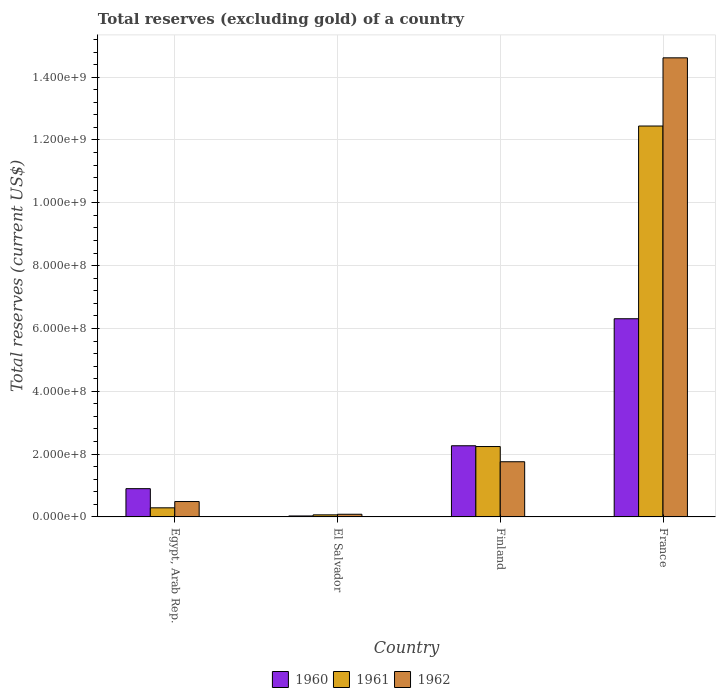How many groups of bars are there?
Your answer should be very brief. 4. Are the number of bars per tick equal to the number of legend labels?
Give a very brief answer. Yes. In how many cases, is the number of bars for a given country not equal to the number of legend labels?
Make the answer very short. 0. What is the total reserves (excluding gold) in 1960 in Egypt, Arab Rep.?
Provide a short and direct response. 9.00e+07. Across all countries, what is the maximum total reserves (excluding gold) in 1961?
Your answer should be very brief. 1.24e+09. Across all countries, what is the minimum total reserves (excluding gold) in 1960?
Give a very brief answer. 3.10e+06. In which country was the total reserves (excluding gold) in 1962 maximum?
Ensure brevity in your answer.  France. In which country was the total reserves (excluding gold) in 1960 minimum?
Your answer should be compact. El Salvador. What is the total total reserves (excluding gold) in 1960 in the graph?
Keep it short and to the point. 9.51e+08. What is the difference between the total reserves (excluding gold) in 1962 in Egypt, Arab Rep. and that in France?
Make the answer very short. -1.41e+09. What is the difference between the total reserves (excluding gold) in 1961 in France and the total reserves (excluding gold) in 1960 in El Salvador?
Your answer should be very brief. 1.24e+09. What is the average total reserves (excluding gold) in 1960 per country?
Your response must be concise. 2.38e+08. What is the difference between the total reserves (excluding gold) of/in 1962 and total reserves (excluding gold) of/in 1961 in France?
Offer a terse response. 2.17e+08. What is the ratio of the total reserves (excluding gold) in 1960 in Egypt, Arab Rep. to that in France?
Offer a terse response. 0.14. What is the difference between the highest and the second highest total reserves (excluding gold) in 1962?
Offer a terse response. -1.27e+08. What is the difference between the highest and the lowest total reserves (excluding gold) in 1961?
Keep it short and to the point. 1.24e+09. In how many countries, is the total reserves (excluding gold) in 1960 greater than the average total reserves (excluding gold) in 1960 taken over all countries?
Ensure brevity in your answer.  1. Is the sum of the total reserves (excluding gold) in 1962 in Egypt, Arab Rep. and Finland greater than the maximum total reserves (excluding gold) in 1961 across all countries?
Provide a short and direct response. No. What does the 2nd bar from the left in El Salvador represents?
Ensure brevity in your answer.  1961. Is it the case that in every country, the sum of the total reserves (excluding gold) in 1962 and total reserves (excluding gold) in 1960 is greater than the total reserves (excluding gold) in 1961?
Give a very brief answer. Yes. How many bars are there?
Give a very brief answer. 12. Are all the bars in the graph horizontal?
Keep it short and to the point. No. How many countries are there in the graph?
Give a very brief answer. 4. What is the difference between two consecutive major ticks on the Y-axis?
Keep it short and to the point. 2.00e+08. Does the graph contain any zero values?
Provide a short and direct response. No. Where does the legend appear in the graph?
Provide a succinct answer. Bottom center. How many legend labels are there?
Make the answer very short. 3. What is the title of the graph?
Provide a short and direct response. Total reserves (excluding gold) of a country. What is the label or title of the X-axis?
Give a very brief answer. Country. What is the label or title of the Y-axis?
Give a very brief answer. Total reserves (current US$). What is the Total reserves (current US$) in 1960 in Egypt, Arab Rep.?
Make the answer very short. 9.00e+07. What is the Total reserves (current US$) in 1961 in Egypt, Arab Rep.?
Provide a short and direct response. 2.90e+07. What is the Total reserves (current US$) in 1962 in Egypt, Arab Rep.?
Give a very brief answer. 4.90e+07. What is the Total reserves (current US$) of 1960 in El Salvador?
Your answer should be compact. 3.10e+06. What is the Total reserves (current US$) of 1961 in El Salvador?
Ensure brevity in your answer.  6.60e+06. What is the Total reserves (current US$) in 1962 in El Salvador?
Give a very brief answer. 8.51e+06. What is the Total reserves (current US$) in 1960 in Finland?
Offer a terse response. 2.27e+08. What is the Total reserves (current US$) in 1961 in Finland?
Ensure brevity in your answer.  2.24e+08. What is the Total reserves (current US$) of 1962 in Finland?
Your answer should be very brief. 1.76e+08. What is the Total reserves (current US$) in 1960 in France?
Offer a very short reply. 6.31e+08. What is the Total reserves (current US$) of 1961 in France?
Offer a very short reply. 1.24e+09. What is the Total reserves (current US$) in 1962 in France?
Ensure brevity in your answer.  1.46e+09. Across all countries, what is the maximum Total reserves (current US$) in 1960?
Provide a succinct answer. 6.31e+08. Across all countries, what is the maximum Total reserves (current US$) in 1961?
Provide a short and direct response. 1.24e+09. Across all countries, what is the maximum Total reserves (current US$) of 1962?
Provide a short and direct response. 1.46e+09. Across all countries, what is the minimum Total reserves (current US$) of 1960?
Ensure brevity in your answer.  3.10e+06. Across all countries, what is the minimum Total reserves (current US$) in 1961?
Ensure brevity in your answer.  6.60e+06. Across all countries, what is the minimum Total reserves (current US$) of 1962?
Make the answer very short. 8.51e+06. What is the total Total reserves (current US$) of 1960 in the graph?
Make the answer very short. 9.51e+08. What is the total Total reserves (current US$) in 1961 in the graph?
Keep it short and to the point. 1.50e+09. What is the total Total reserves (current US$) of 1962 in the graph?
Your answer should be compact. 1.69e+09. What is the difference between the Total reserves (current US$) of 1960 in Egypt, Arab Rep. and that in El Salvador?
Keep it short and to the point. 8.69e+07. What is the difference between the Total reserves (current US$) in 1961 in Egypt, Arab Rep. and that in El Salvador?
Make the answer very short. 2.24e+07. What is the difference between the Total reserves (current US$) in 1962 in Egypt, Arab Rep. and that in El Salvador?
Keep it short and to the point. 4.05e+07. What is the difference between the Total reserves (current US$) of 1960 in Egypt, Arab Rep. and that in Finland?
Offer a very short reply. -1.37e+08. What is the difference between the Total reserves (current US$) of 1961 in Egypt, Arab Rep. and that in Finland?
Your answer should be compact. -1.95e+08. What is the difference between the Total reserves (current US$) in 1962 in Egypt, Arab Rep. and that in Finland?
Provide a short and direct response. -1.27e+08. What is the difference between the Total reserves (current US$) of 1960 in Egypt, Arab Rep. and that in France?
Ensure brevity in your answer.  -5.41e+08. What is the difference between the Total reserves (current US$) in 1961 in Egypt, Arab Rep. and that in France?
Give a very brief answer. -1.22e+09. What is the difference between the Total reserves (current US$) in 1962 in Egypt, Arab Rep. and that in France?
Ensure brevity in your answer.  -1.41e+09. What is the difference between the Total reserves (current US$) of 1960 in El Salvador and that in Finland?
Give a very brief answer. -2.23e+08. What is the difference between the Total reserves (current US$) of 1961 in El Salvador and that in Finland?
Make the answer very short. -2.17e+08. What is the difference between the Total reserves (current US$) of 1962 in El Salvador and that in Finland?
Provide a succinct answer. -1.67e+08. What is the difference between the Total reserves (current US$) in 1960 in El Salvador and that in France?
Ensure brevity in your answer.  -6.28e+08. What is the difference between the Total reserves (current US$) in 1961 in El Salvador and that in France?
Provide a short and direct response. -1.24e+09. What is the difference between the Total reserves (current US$) in 1962 in El Salvador and that in France?
Provide a short and direct response. -1.45e+09. What is the difference between the Total reserves (current US$) in 1960 in Finland and that in France?
Keep it short and to the point. -4.04e+08. What is the difference between the Total reserves (current US$) in 1961 in Finland and that in France?
Ensure brevity in your answer.  -1.02e+09. What is the difference between the Total reserves (current US$) of 1962 in Finland and that in France?
Provide a succinct answer. -1.29e+09. What is the difference between the Total reserves (current US$) of 1960 in Egypt, Arab Rep. and the Total reserves (current US$) of 1961 in El Salvador?
Offer a very short reply. 8.34e+07. What is the difference between the Total reserves (current US$) in 1960 in Egypt, Arab Rep. and the Total reserves (current US$) in 1962 in El Salvador?
Offer a terse response. 8.15e+07. What is the difference between the Total reserves (current US$) in 1961 in Egypt, Arab Rep. and the Total reserves (current US$) in 1962 in El Salvador?
Give a very brief answer. 2.05e+07. What is the difference between the Total reserves (current US$) in 1960 in Egypt, Arab Rep. and the Total reserves (current US$) in 1961 in Finland?
Keep it short and to the point. -1.34e+08. What is the difference between the Total reserves (current US$) of 1960 in Egypt, Arab Rep. and the Total reserves (current US$) of 1962 in Finland?
Your answer should be very brief. -8.57e+07. What is the difference between the Total reserves (current US$) of 1961 in Egypt, Arab Rep. and the Total reserves (current US$) of 1962 in Finland?
Provide a short and direct response. -1.47e+08. What is the difference between the Total reserves (current US$) in 1960 in Egypt, Arab Rep. and the Total reserves (current US$) in 1961 in France?
Keep it short and to the point. -1.15e+09. What is the difference between the Total reserves (current US$) of 1960 in Egypt, Arab Rep. and the Total reserves (current US$) of 1962 in France?
Provide a short and direct response. -1.37e+09. What is the difference between the Total reserves (current US$) in 1961 in Egypt, Arab Rep. and the Total reserves (current US$) in 1962 in France?
Your answer should be compact. -1.43e+09. What is the difference between the Total reserves (current US$) of 1960 in El Salvador and the Total reserves (current US$) of 1961 in Finland?
Your answer should be compact. -2.21e+08. What is the difference between the Total reserves (current US$) of 1960 in El Salvador and the Total reserves (current US$) of 1962 in Finland?
Ensure brevity in your answer.  -1.73e+08. What is the difference between the Total reserves (current US$) in 1961 in El Salvador and the Total reserves (current US$) in 1962 in Finland?
Provide a succinct answer. -1.69e+08. What is the difference between the Total reserves (current US$) of 1960 in El Salvador and the Total reserves (current US$) of 1961 in France?
Provide a short and direct response. -1.24e+09. What is the difference between the Total reserves (current US$) in 1960 in El Salvador and the Total reserves (current US$) in 1962 in France?
Keep it short and to the point. -1.46e+09. What is the difference between the Total reserves (current US$) of 1961 in El Salvador and the Total reserves (current US$) of 1962 in France?
Give a very brief answer. -1.45e+09. What is the difference between the Total reserves (current US$) in 1960 in Finland and the Total reserves (current US$) in 1961 in France?
Give a very brief answer. -1.02e+09. What is the difference between the Total reserves (current US$) in 1960 in Finland and the Total reserves (current US$) in 1962 in France?
Keep it short and to the point. -1.23e+09. What is the difference between the Total reserves (current US$) in 1961 in Finland and the Total reserves (current US$) in 1962 in France?
Ensure brevity in your answer.  -1.24e+09. What is the average Total reserves (current US$) in 1960 per country?
Make the answer very short. 2.38e+08. What is the average Total reserves (current US$) of 1961 per country?
Give a very brief answer. 3.76e+08. What is the average Total reserves (current US$) in 1962 per country?
Keep it short and to the point. 4.24e+08. What is the difference between the Total reserves (current US$) of 1960 and Total reserves (current US$) of 1961 in Egypt, Arab Rep.?
Keep it short and to the point. 6.10e+07. What is the difference between the Total reserves (current US$) of 1960 and Total reserves (current US$) of 1962 in Egypt, Arab Rep.?
Give a very brief answer. 4.10e+07. What is the difference between the Total reserves (current US$) in 1961 and Total reserves (current US$) in 1962 in Egypt, Arab Rep.?
Offer a terse response. -2.00e+07. What is the difference between the Total reserves (current US$) of 1960 and Total reserves (current US$) of 1961 in El Salvador?
Your response must be concise. -3.50e+06. What is the difference between the Total reserves (current US$) in 1960 and Total reserves (current US$) in 1962 in El Salvador?
Offer a very short reply. -5.41e+06. What is the difference between the Total reserves (current US$) of 1961 and Total reserves (current US$) of 1962 in El Salvador?
Your answer should be compact. -1.91e+06. What is the difference between the Total reserves (current US$) of 1960 and Total reserves (current US$) of 1961 in Finland?
Your answer should be compact. 2.50e+06. What is the difference between the Total reserves (current US$) of 1960 and Total reserves (current US$) of 1962 in Finland?
Provide a succinct answer. 5.09e+07. What is the difference between the Total reserves (current US$) in 1961 and Total reserves (current US$) in 1962 in Finland?
Your response must be concise. 4.84e+07. What is the difference between the Total reserves (current US$) in 1960 and Total reserves (current US$) in 1961 in France?
Offer a terse response. -6.14e+08. What is the difference between the Total reserves (current US$) in 1960 and Total reserves (current US$) in 1962 in France?
Keep it short and to the point. -8.31e+08. What is the difference between the Total reserves (current US$) of 1961 and Total reserves (current US$) of 1962 in France?
Give a very brief answer. -2.17e+08. What is the ratio of the Total reserves (current US$) of 1960 in Egypt, Arab Rep. to that in El Salvador?
Give a very brief answer. 29.03. What is the ratio of the Total reserves (current US$) of 1961 in Egypt, Arab Rep. to that in El Salvador?
Give a very brief answer. 4.39. What is the ratio of the Total reserves (current US$) in 1962 in Egypt, Arab Rep. to that in El Salvador?
Offer a very short reply. 5.76. What is the ratio of the Total reserves (current US$) in 1960 in Egypt, Arab Rep. to that in Finland?
Your answer should be compact. 0.4. What is the ratio of the Total reserves (current US$) of 1961 in Egypt, Arab Rep. to that in Finland?
Your response must be concise. 0.13. What is the ratio of the Total reserves (current US$) of 1962 in Egypt, Arab Rep. to that in Finland?
Offer a terse response. 0.28. What is the ratio of the Total reserves (current US$) in 1960 in Egypt, Arab Rep. to that in France?
Your response must be concise. 0.14. What is the ratio of the Total reserves (current US$) of 1961 in Egypt, Arab Rep. to that in France?
Ensure brevity in your answer.  0.02. What is the ratio of the Total reserves (current US$) of 1962 in Egypt, Arab Rep. to that in France?
Give a very brief answer. 0.03. What is the ratio of the Total reserves (current US$) of 1960 in El Salvador to that in Finland?
Your answer should be very brief. 0.01. What is the ratio of the Total reserves (current US$) of 1961 in El Salvador to that in Finland?
Ensure brevity in your answer.  0.03. What is the ratio of the Total reserves (current US$) in 1962 in El Salvador to that in Finland?
Your answer should be very brief. 0.05. What is the ratio of the Total reserves (current US$) of 1960 in El Salvador to that in France?
Offer a very short reply. 0. What is the ratio of the Total reserves (current US$) of 1961 in El Salvador to that in France?
Keep it short and to the point. 0.01. What is the ratio of the Total reserves (current US$) of 1962 in El Salvador to that in France?
Keep it short and to the point. 0.01. What is the ratio of the Total reserves (current US$) of 1960 in Finland to that in France?
Provide a short and direct response. 0.36. What is the ratio of the Total reserves (current US$) of 1961 in Finland to that in France?
Offer a very short reply. 0.18. What is the ratio of the Total reserves (current US$) in 1962 in Finland to that in France?
Make the answer very short. 0.12. What is the difference between the highest and the second highest Total reserves (current US$) in 1960?
Make the answer very short. 4.04e+08. What is the difference between the highest and the second highest Total reserves (current US$) in 1961?
Ensure brevity in your answer.  1.02e+09. What is the difference between the highest and the second highest Total reserves (current US$) of 1962?
Your answer should be compact. 1.29e+09. What is the difference between the highest and the lowest Total reserves (current US$) of 1960?
Offer a very short reply. 6.28e+08. What is the difference between the highest and the lowest Total reserves (current US$) in 1961?
Provide a succinct answer. 1.24e+09. What is the difference between the highest and the lowest Total reserves (current US$) in 1962?
Offer a terse response. 1.45e+09. 